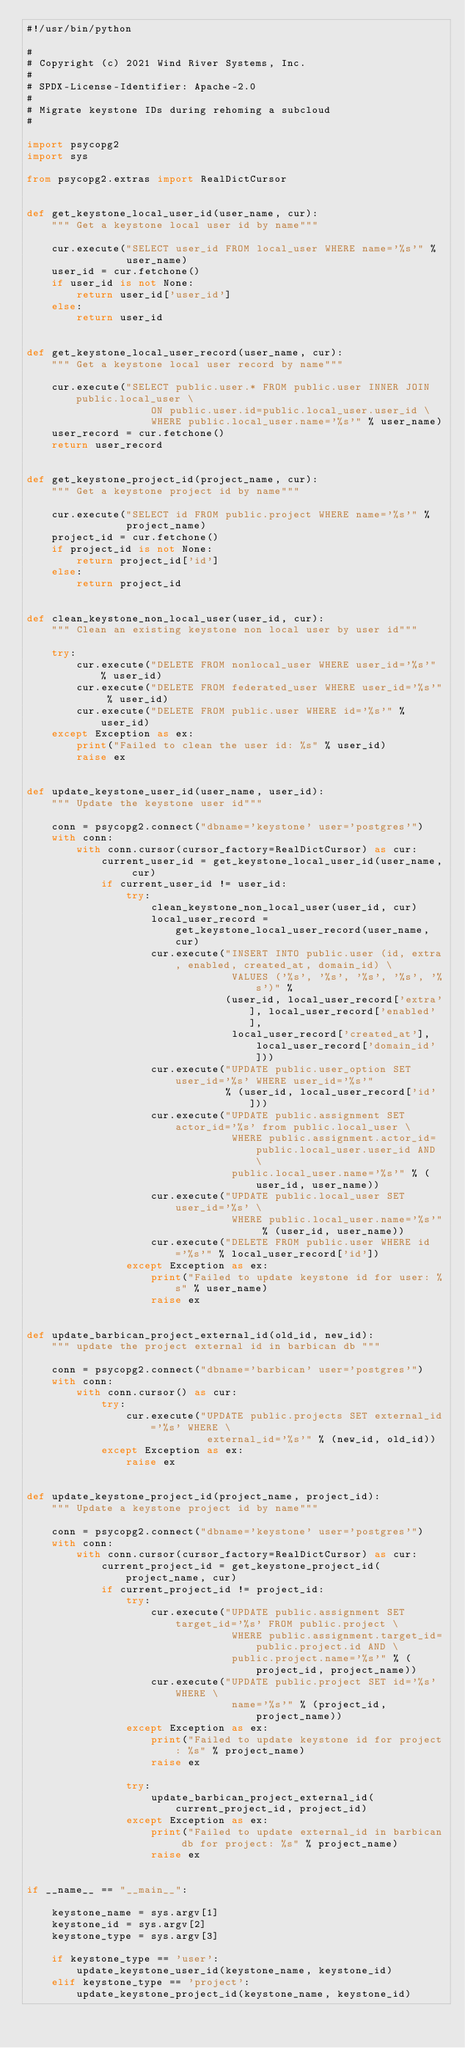<code> <loc_0><loc_0><loc_500><loc_500><_Python_>#!/usr/bin/python

#
# Copyright (c) 2021 Wind River Systems, Inc.
#
# SPDX-License-Identifier: Apache-2.0
#
# Migrate keystone IDs during rehoming a subcloud
#

import psycopg2
import sys

from psycopg2.extras import RealDictCursor


def get_keystone_local_user_id(user_name, cur):
    """ Get a keystone local user id by name"""

    cur.execute("SELECT user_id FROM local_user WHERE name='%s'" %
                user_name)
    user_id = cur.fetchone()
    if user_id is not None:
        return user_id['user_id']
    else:
        return user_id


def get_keystone_local_user_record(user_name, cur):
    """ Get a keystone local user record by name"""

    cur.execute("SELECT public.user.* FROM public.user INNER JOIN public.local_user \
                    ON public.user.id=public.local_user.user_id \
                    WHERE public.local_user.name='%s'" % user_name)
    user_record = cur.fetchone()
    return user_record


def get_keystone_project_id(project_name, cur):
    """ Get a keystone project id by name"""

    cur.execute("SELECT id FROM public.project WHERE name='%s'" %
                project_name)
    project_id = cur.fetchone()
    if project_id is not None:
        return project_id['id']
    else:
        return project_id


def clean_keystone_non_local_user(user_id, cur):
    """ Clean an existing keystone non local user by user id"""

    try:
        cur.execute("DELETE FROM nonlocal_user WHERE user_id='%s'" % user_id)
        cur.execute("DELETE FROM federated_user WHERE user_id='%s'" % user_id)
        cur.execute("DELETE FROM public.user WHERE id='%s'" % user_id)
    except Exception as ex:
        print("Failed to clean the user id: %s" % user_id)
        raise ex


def update_keystone_user_id(user_name, user_id):
    """ Update the keystone user id"""

    conn = psycopg2.connect("dbname='keystone' user='postgres'")
    with conn:
        with conn.cursor(cursor_factory=RealDictCursor) as cur:
            current_user_id = get_keystone_local_user_id(user_name, cur)
            if current_user_id != user_id:
                try:
                    clean_keystone_non_local_user(user_id, cur)
                    local_user_record = get_keystone_local_user_record(user_name, cur)
                    cur.execute("INSERT INTO public.user (id, extra, enabled, created_at, domain_id) \
                                 VALUES ('%s', '%s', '%s', '%s', '%s')" %
                                (user_id, local_user_record['extra'], local_user_record['enabled'],
                                 local_user_record['created_at'], local_user_record['domain_id']))
                    cur.execute("UPDATE public.user_option SET user_id='%s' WHERE user_id='%s'"
                                % (user_id, local_user_record['id']))
                    cur.execute("UPDATE public.assignment SET actor_id='%s' from public.local_user \
                                 WHERE public.assignment.actor_id=public.local_user.user_id AND \
                                 public.local_user.name='%s'" % (user_id, user_name))
                    cur.execute("UPDATE public.local_user SET user_id='%s' \
                                 WHERE public.local_user.name='%s'" % (user_id, user_name))
                    cur.execute("DELETE FROM public.user WHERE id='%s'" % local_user_record['id'])
                except Exception as ex:
                    print("Failed to update keystone id for user: %s" % user_name)
                    raise ex


def update_barbican_project_external_id(old_id, new_id):
    """ update the project external id in barbican db """

    conn = psycopg2.connect("dbname='barbican' user='postgres'")
    with conn:
        with conn.cursor() as cur:
            try:
                cur.execute("UPDATE public.projects SET external_id='%s' WHERE \
                             external_id='%s'" % (new_id, old_id))
            except Exception as ex:
                raise ex


def update_keystone_project_id(project_name, project_id):
    """ Update a keystone project id by name"""

    conn = psycopg2.connect("dbname='keystone' user='postgres'")
    with conn:
        with conn.cursor(cursor_factory=RealDictCursor) as cur:
            current_project_id = get_keystone_project_id(project_name, cur)
            if current_project_id != project_id:
                try:
                    cur.execute("UPDATE public.assignment SET target_id='%s' FROM public.project \
                                 WHERE public.assignment.target_id=public.project.id AND \
                                 public.project.name='%s'" % (project_id, project_name))
                    cur.execute("UPDATE public.project SET id='%s' WHERE \
                                 name='%s'" % (project_id, project_name))
                except Exception as ex:
                    print("Failed to update keystone id for project: %s" % project_name)
                    raise ex

                try:
                    update_barbican_project_external_id(current_project_id, project_id)
                except Exception as ex:
                    print("Failed to update external_id in barbican db for project: %s" % project_name)
                    raise ex


if __name__ == "__main__":

    keystone_name = sys.argv[1]
    keystone_id = sys.argv[2]
    keystone_type = sys.argv[3]

    if keystone_type == 'user':
        update_keystone_user_id(keystone_name, keystone_id)
    elif keystone_type == 'project':
        update_keystone_project_id(keystone_name, keystone_id)
</code> 